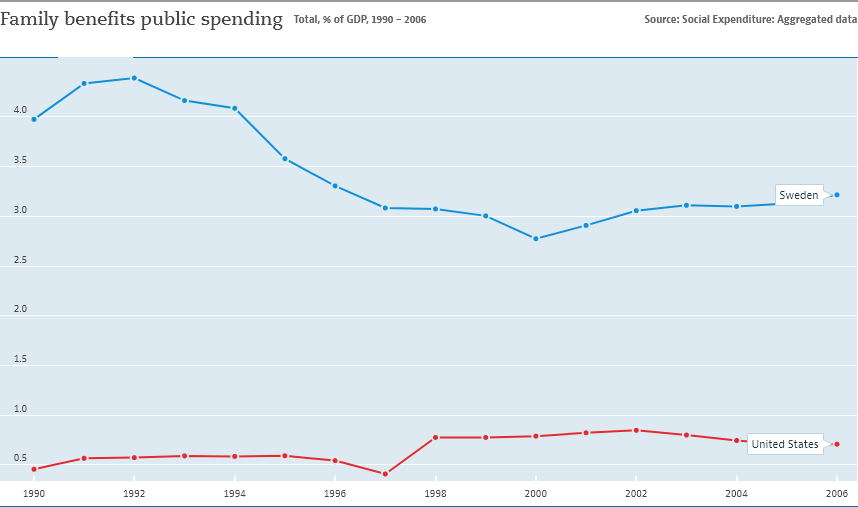Draw attention to some important aspects in this diagram. In 1992, the disparity between the two lines was at its greatest level. The graph shows the relationship between family benefits and public spending in a country. It is indicated that family benefits are directly related to public spending. 